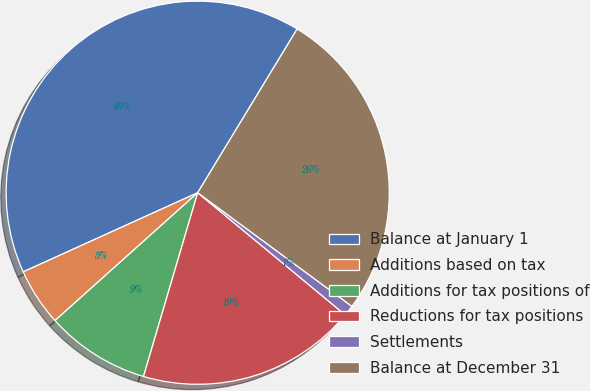Convert chart to OTSL. <chart><loc_0><loc_0><loc_500><loc_500><pie_chart><fcel>Balance at January 1<fcel>Additions based on tax<fcel>Additions for tax positions of<fcel>Reductions for tax positions<fcel>Settlements<fcel>Balance at December 31<nl><fcel>40.47%<fcel>4.85%<fcel>8.81%<fcel>18.56%<fcel>0.9%<fcel>26.42%<nl></chart> 